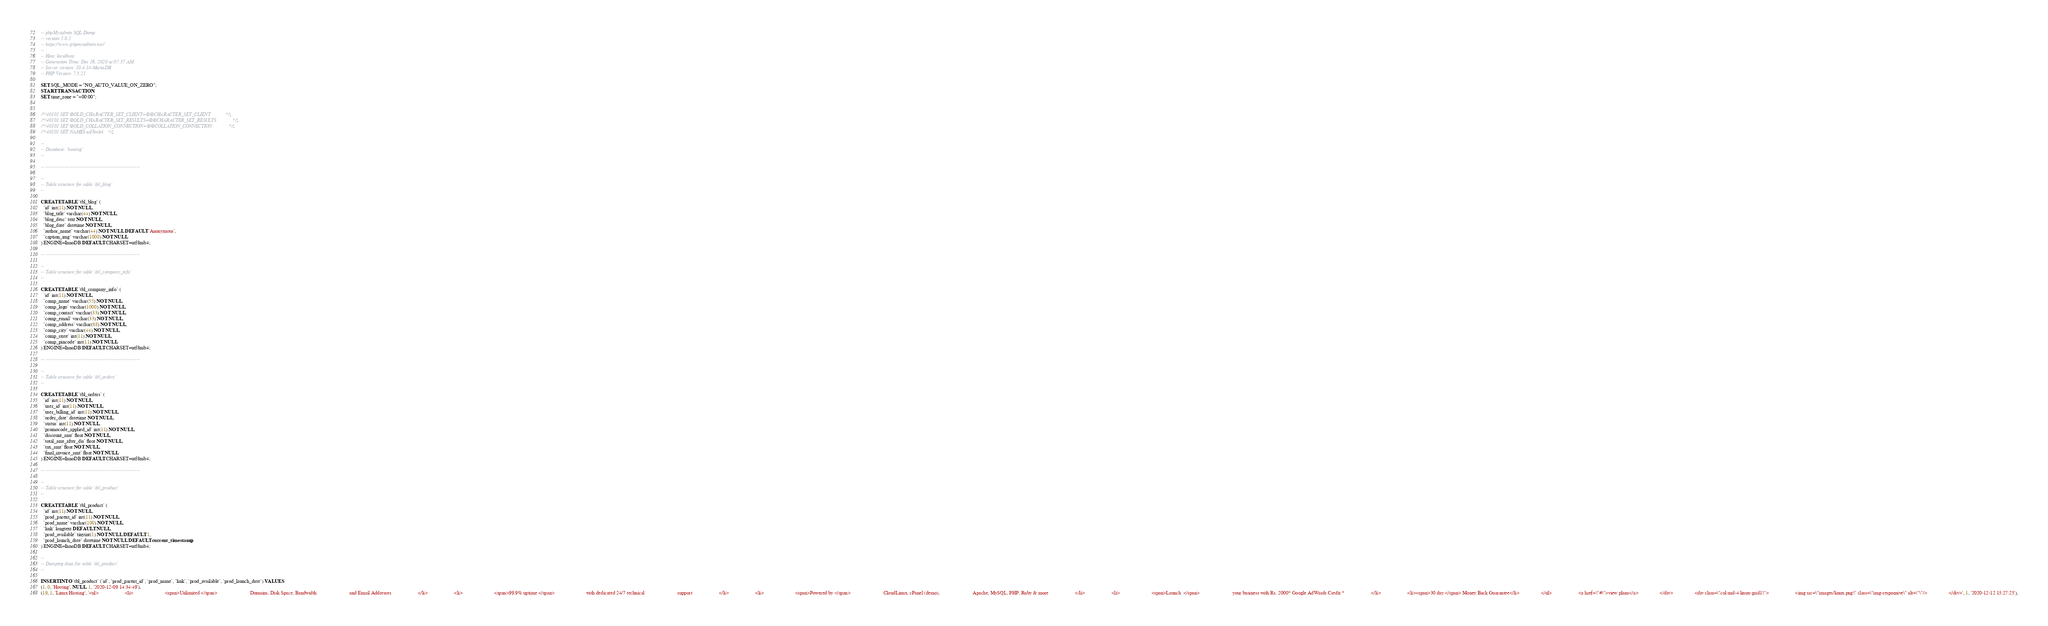<code> <loc_0><loc_0><loc_500><loc_500><_SQL_>-- phpMyAdmin SQL Dump
-- version 5.0.2
-- https://www.phpmyadmin.net/
--
-- Host: localhost
-- Generation Time: Dec 16, 2020 at 07:37 AM
-- Server version: 10.4.14-MariaDB
-- PHP Version: 7.3.21

SET SQL_MODE = "NO_AUTO_VALUE_ON_ZERO";
START TRANSACTION;
SET time_zone = "+00:00";


/*!40101 SET @OLD_CHARACTER_SET_CLIENT=@@CHARACTER_SET_CLIENT */;
/*!40101 SET @OLD_CHARACTER_SET_RESULTS=@@CHARACTER_SET_RESULTS */;
/*!40101 SET @OLD_COLLATION_CONNECTION=@@COLLATION_CONNECTION */;
/*!40101 SET NAMES utf8mb4 */;

--
-- Database: `hosting`
--

-- --------------------------------------------------------

--
-- Table structure for table `tbl_blog`
--

CREATE TABLE `tbl_blog` (
  `id` int(11) NOT NULL,
  `blog_title` varchar(44) NOT NULL,
  `blog_desc` text NOT NULL,
  `blog_date` datetime NOT NULL,
  `author_name` varchar(44) NOT NULL DEFAULT 'Anonymous',
  `caption_img` varchar(1000) NOT NULL
) ENGINE=InnoDB DEFAULT CHARSET=utf8mb4;

-- --------------------------------------------------------

--
-- Table structure for table `tbl_company_info`
--

CREATE TABLE `tbl_company_info` (
  `id` int(11) NOT NULL,
  `comp_name` varchar(55) NOT NULL,
  `comp_logo` varchar(1000) NOT NULL,
  `comp_contact` varchar(33) NOT NULL,
  `comp_email` varchar(33) NOT NULL,
  `comp_address` varchar(88) NOT NULL,
  `comp_city` varchar(44) NOT NULL,
  `comp_state` int(11) NOT NULL,
  `comp_pincode` int(11) NOT NULL
) ENGINE=InnoDB DEFAULT CHARSET=utf8mb4;

-- --------------------------------------------------------

--
-- Table structure for table `tbl_orders`
--

CREATE TABLE `tbl_orders` (
  `id` int(11) NOT NULL,
  `user_id` int(11) NOT NULL,
  `user_billing_id` int(11) NOT NULL,
  `order_date` datetime NOT NULL,
  `status` int(11) NOT NULL,
  `promocode_applied_id` int(11) NOT NULL,
  `discount_amt` float NOT NULL,
  `total_amt_after_dis` float NOT NULL,
  `tax_amt` float NOT NULL,
  `final_invoice_amt` float NOT NULL
) ENGINE=InnoDB DEFAULT CHARSET=utf8mb4;

-- --------------------------------------------------------

--
-- Table structure for table `tbl_product`
--

CREATE TABLE `tbl_product` (
  `id` int(11) NOT NULL,
  `prod_parent_id` int(11) NOT NULL,
  `prod_name` varchar(100) NOT NULL,
  `link` longtext DEFAULT NULL,
  `prod_available` tinyint(1) NOT NULL DEFAULT 1,
  `prod_launch_date` datetime NOT NULL DEFAULT current_timestamp()
) ENGINE=InnoDB DEFAULT CHARSET=utf8mb4;

--
-- Dumping data for table `tbl_product`
--

INSERT INTO `tbl_product` (`id`, `prod_parent_id`, `prod_name`, `link`, `prod_available`, `prod_launch_date`) VALUES
(1, 0, 'Hosting', NULL, 1, '2020-12-09 14:34:49'),
(19, 1, 'Linux Hosting', '<ul>                     <li>                         <span>Unlimited </span>                          Domains, Disk Space, Bandwidth                          and Email Addresses                     </li>                     <li>                         <span>99.9% uptime </span>                         with dedicated 24/7 technical                          support                     </li>                     <li>                         <span>Powered by </span>                          CloudLinux, cPanel (demo),                          Apache, MySQL, PHP, Ruby & more                     </li>                     <li>                         <span>Launch  </span>                          your business with Rs. 2000* Google AdWords Credit *                     </li>                     <li><span>30 day </span> Money Back Guarantee</li>                 </ul>                     <a href=\"#\">view plans</a>                 </div>                 <div class=\"col-md-4 linux-grid1\">                     <img src=\"images/linux.png\" class=\"img-responsive\" alt=\"\"/>                 </div>', 1, '2020-12-12 15:27:25'),</code> 